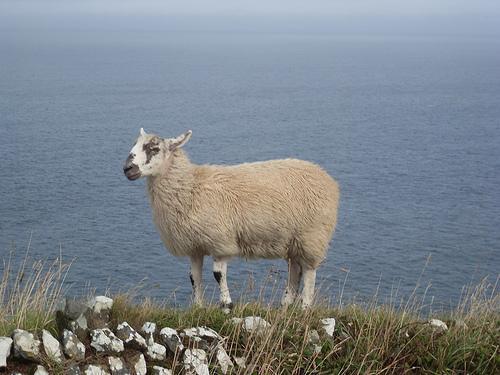How many animals are shown in this photo?
Give a very brief answer. 1. 